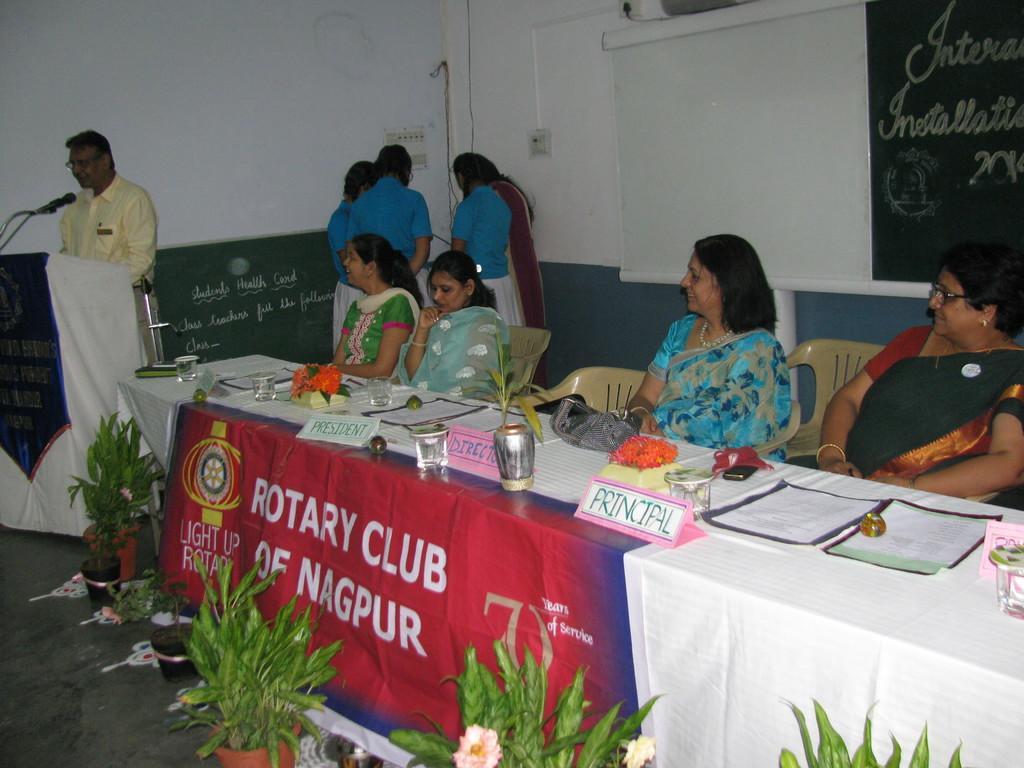How would you summarize this image in a sentence or two? In this picture there are four women sitting on the chair. There is a glass , paper on the table. There is a flower pot. There is a man standing. There are few persons standing at the corner. There is a poster. 